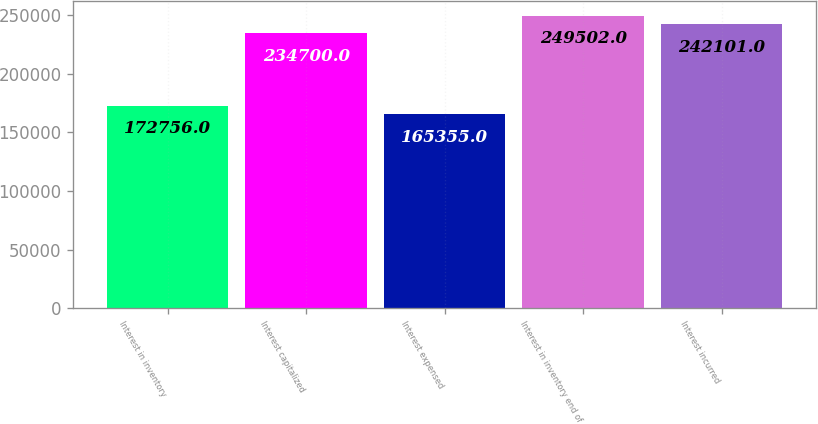<chart> <loc_0><loc_0><loc_500><loc_500><bar_chart><fcel>Interest in inventory<fcel>Interest capitalized<fcel>Interest expensed<fcel>Interest in inventory end of<fcel>Interest incurred<nl><fcel>172756<fcel>234700<fcel>165355<fcel>249502<fcel>242101<nl></chart> 